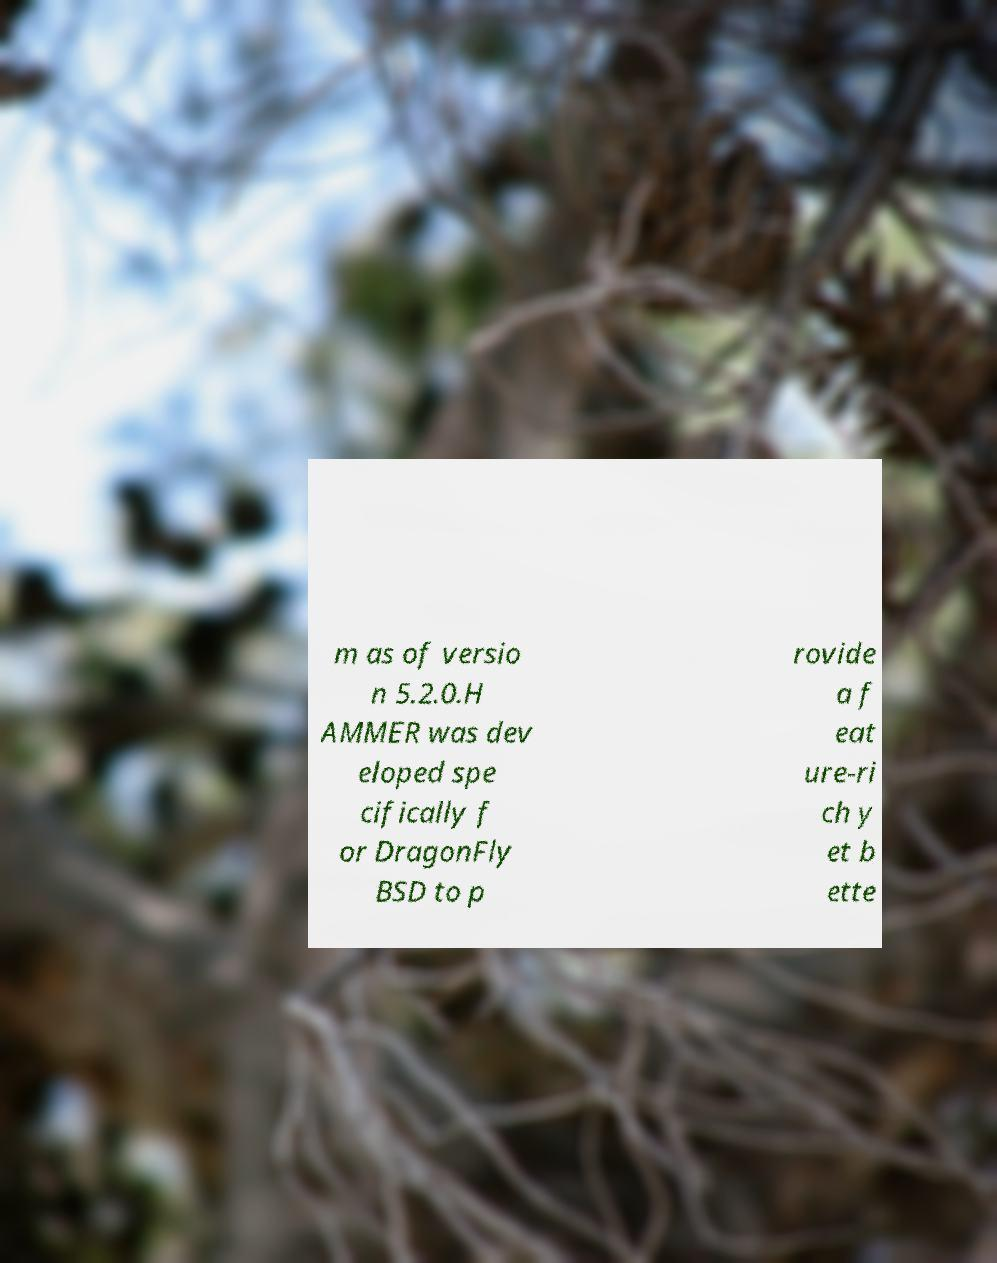What messages or text are displayed in this image? I need them in a readable, typed format. m as of versio n 5.2.0.H AMMER was dev eloped spe cifically f or DragonFly BSD to p rovide a f eat ure-ri ch y et b ette 